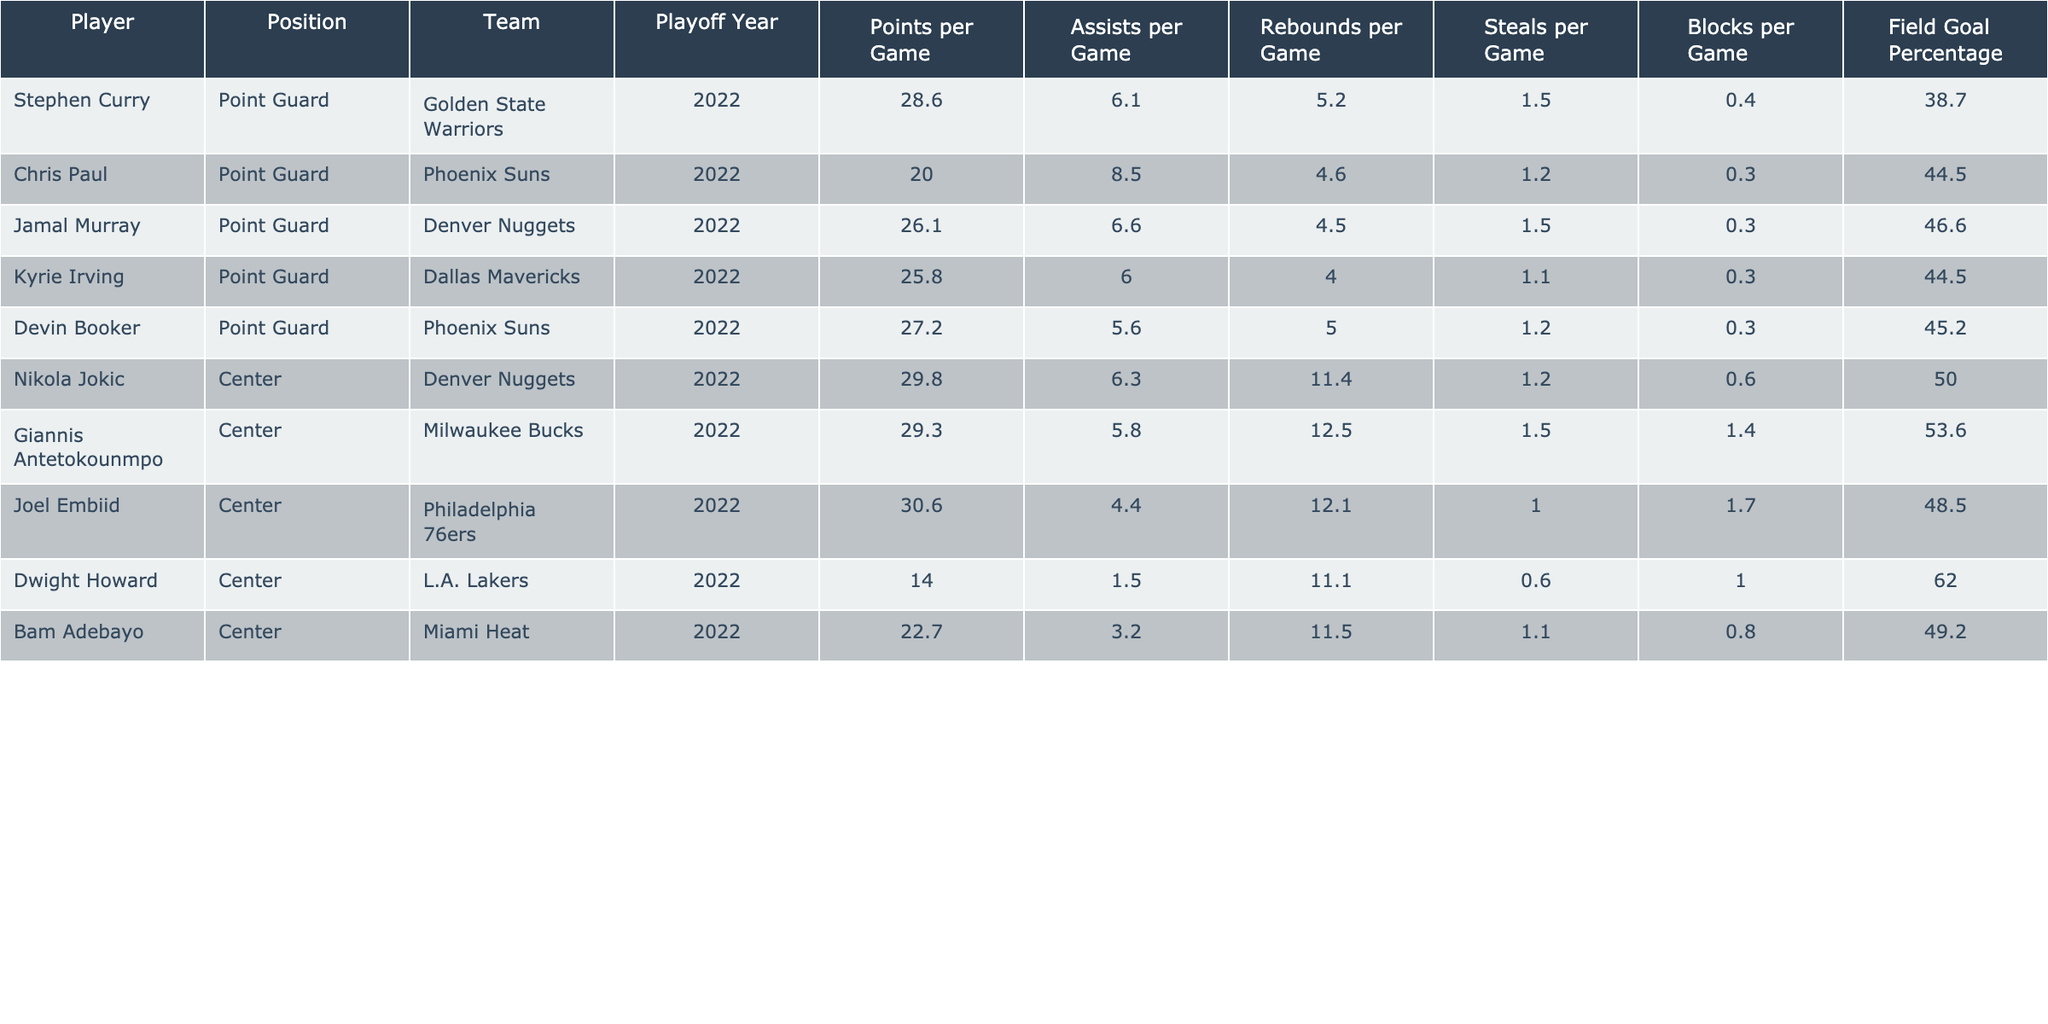What is the highest points per game scored by a player in the table? The highest points per game in the table is found by looking at the "Points per Game" column. Joel Embiid has the highest with 30.6 points per game.
Answer: 30.6 Which point guard has the highest assists per game? By reviewing the "Assists per Game" column specifically for point guards, Chris Paul has the highest at 8.5 assists per game.
Answer: 8.5 What is the average points per game among centers? To find the average, sum the points per game for all centers (29.8, 29.3, 30.6, 14.0, 22.7) which totals to 126.4. There are five centers, so the average is 126.4/5 = 25.28 points per game.
Answer: 25.28 Do all players have a field goal percentage above 40%? To answer this, I check the "Field Goal Percentage" column for all players. Dwight Howard has a field goal percentage of 62.0%, but Chris Paul has 44.5%, and Jamal Murray has 46.6%. Therefore, the statement is true; all percentages are above 40%.
Answer: Yes How many players scored more than 25 points per game in the playoffs? I will count the players with points per game greater than 25 from the "Points per Game" column. The players are Stephen Curry, Jamal Murray, Devin Booker, Nikola Jokic, Giannis Antetokounmpo, and Joel Embiid, resulting in a total of six players.
Answer: 6 Which player had the highest rebounds per game, and how many? I will examine the "Rebounds per Game" column to find the highest value. Nikola Jokic has the highest with 11.4 rebounds per game.
Answer: 11.4 What is the difference in points per game between the highest-scoring center and the highest-scoring point guard? First, identify the highest points per game for centers (Joel Embiid with 30.6) and point guards (Stephen Curry with 28.6). The difference is calculated as 30.6 - 28.6 = 2.0 points.
Answer: 2.0 Is Giannis Antetokounmpo better at scoring than the average points per game of all point guards listed? First, find the average points per game for point guards. Their points are 28.6, 20.0, 26.1, 25.8, and 27.2, totaling 127.7. The average is 127.7/5 = 25.54. Giannis scores 29.3, which is higher. Hence, he is better at scoring than the average.
Answer: Yes Which position has the best average field goal percentage? Calculate the average field goal percentage for both positions. For point guards: (38.7 + 44.5 + 46.6 + 44.5 + 45.2) = 219.5 / 5 = 43.9%. For centers: (50.0 + 53.6 + 48.5 + 62.0 + 49.2) = 263.3 / 5 = 52.66%. Centers have a higher average.
Answer: Centers How many total assists did all players in the table achieve? I will sum the assists per game for all players: (6.1 + 8.5 + 6.6 + 6.0 + 5.6 + 6.3 + 5.8 + 1.5 + 3.2) = 49.6 assists per game.
Answer: 49.6 